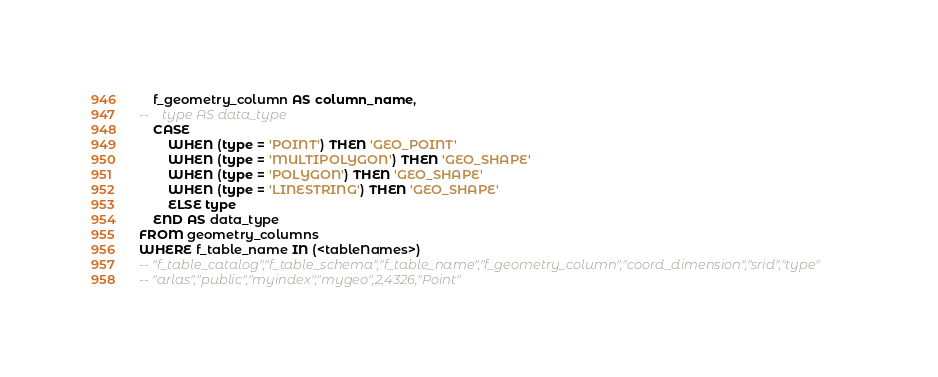<code> <loc_0><loc_0><loc_500><loc_500><_SQL_>    f_geometry_column AS column_name,
--    type AS data_type
    CASE
        WHEN (type = 'POINT') THEN 'GEO_POINT'
        WHEN (type = 'MULTIPOLYGON') THEN 'GEO_SHAPE'
        WHEN (type = 'POLYGON') THEN 'GEO_SHAPE'
        WHEN (type = 'LINESTRING') THEN 'GEO_SHAPE'
        ELSE type
    END AS data_type
FROM geometry_columns
WHERE f_table_name IN (<tableNames>)
-- "f_table_catalog","f_table_schema","f_table_name","f_geometry_column","coord_dimension","srid","type"
-- "arlas","public","myindex","mygeo",2,4326,"Point"</code> 